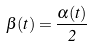Convert formula to latex. <formula><loc_0><loc_0><loc_500><loc_500>\beta ( t ) = \frac { \alpha ( t ) } { 2 }</formula> 